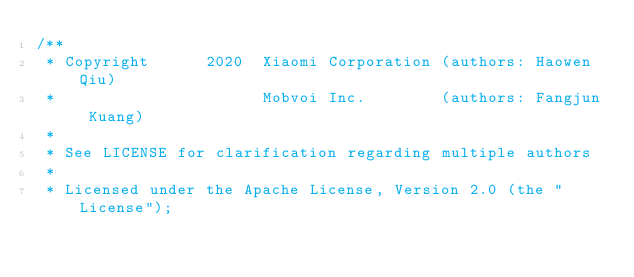Convert code to text. <code><loc_0><loc_0><loc_500><loc_500><_Cuda_>/**
 * Copyright      2020  Xiaomi Corporation (authors: Haowen Qiu)
 *                      Mobvoi Inc.        (authors: Fangjun Kuang)
 *
 * See LICENSE for clarification regarding multiple authors
 *
 * Licensed under the Apache License, Version 2.0 (the "License");</code> 